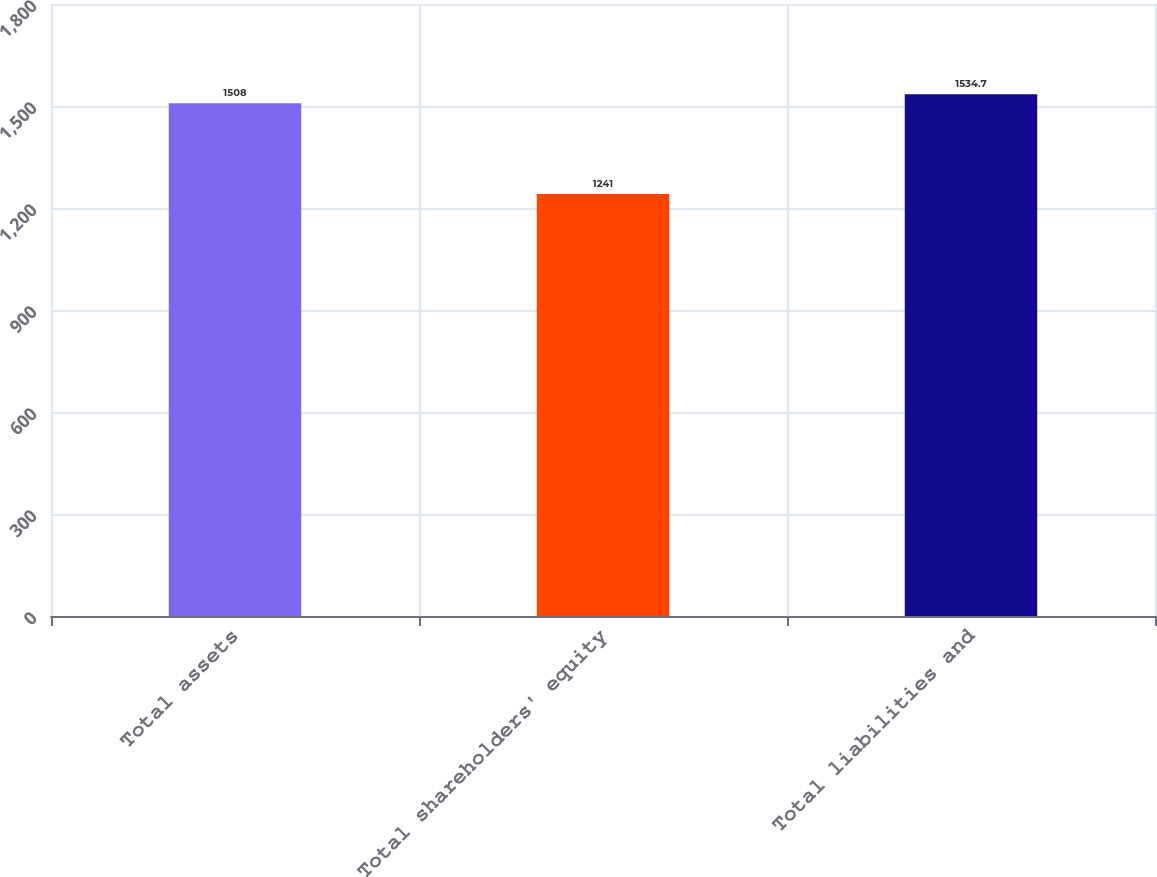<chart> <loc_0><loc_0><loc_500><loc_500><bar_chart><fcel>Total assets<fcel>Total shareholders' equity<fcel>Total liabilities and<nl><fcel>1508<fcel>1241<fcel>1534.7<nl></chart> 